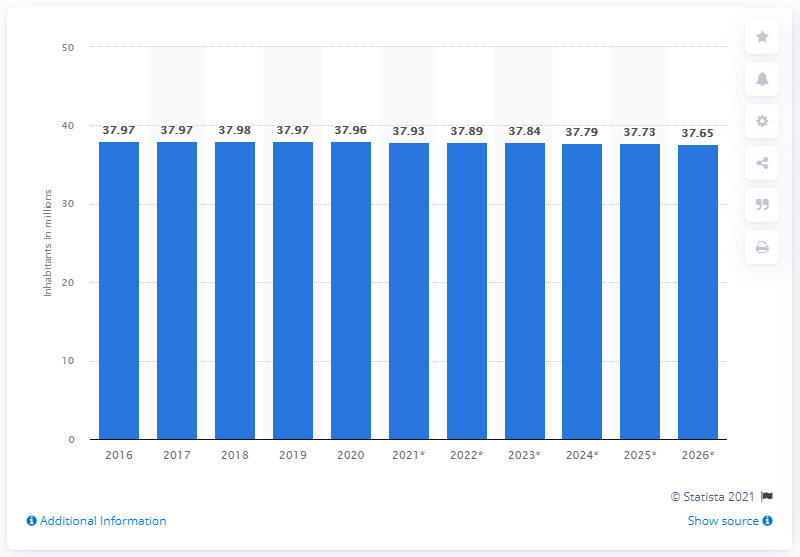What was the population of Poland in 2020?
 37.65 